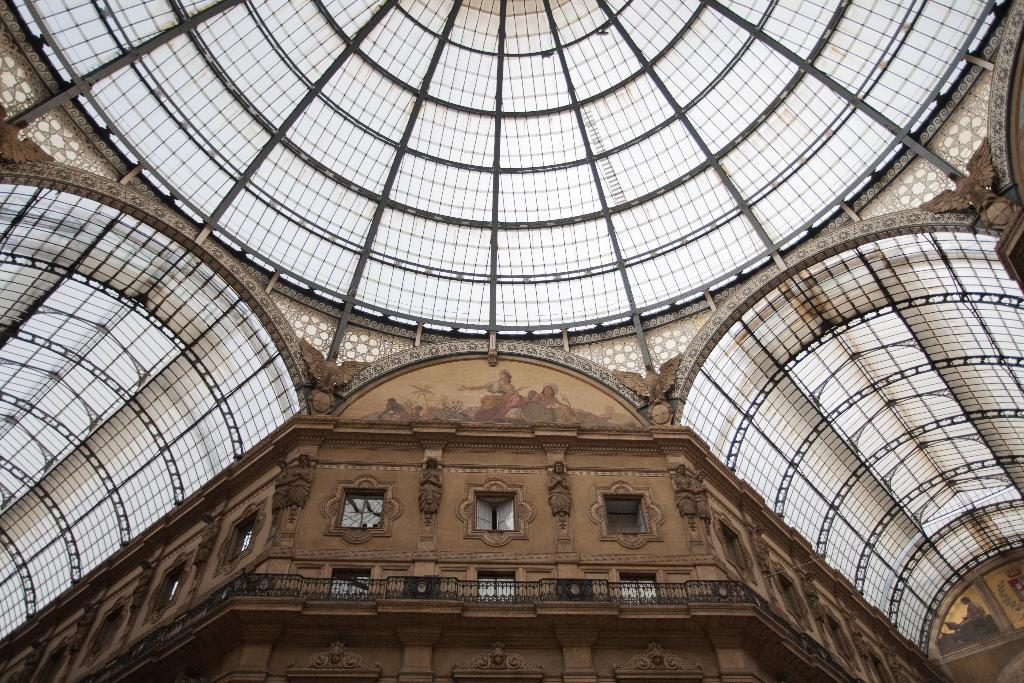What is located at the bottom of the image? There is a building and sculptures at the bottom of the image. What else can be seen at the bottom of the image? There are objects at the top of the image. What separates the top and bottom of the image? There is a wall at the top of the image. What type of grass can be seen growing on the wall at the top of the image? There is no grass present in the image; the wall at the top of the image does not have any vegetation. What time of day is depicted in the image, as indicated by the hour on the wall? There is no hour or time indication present in the image; the wall at the top of the image does not have any clock or time-related features. 